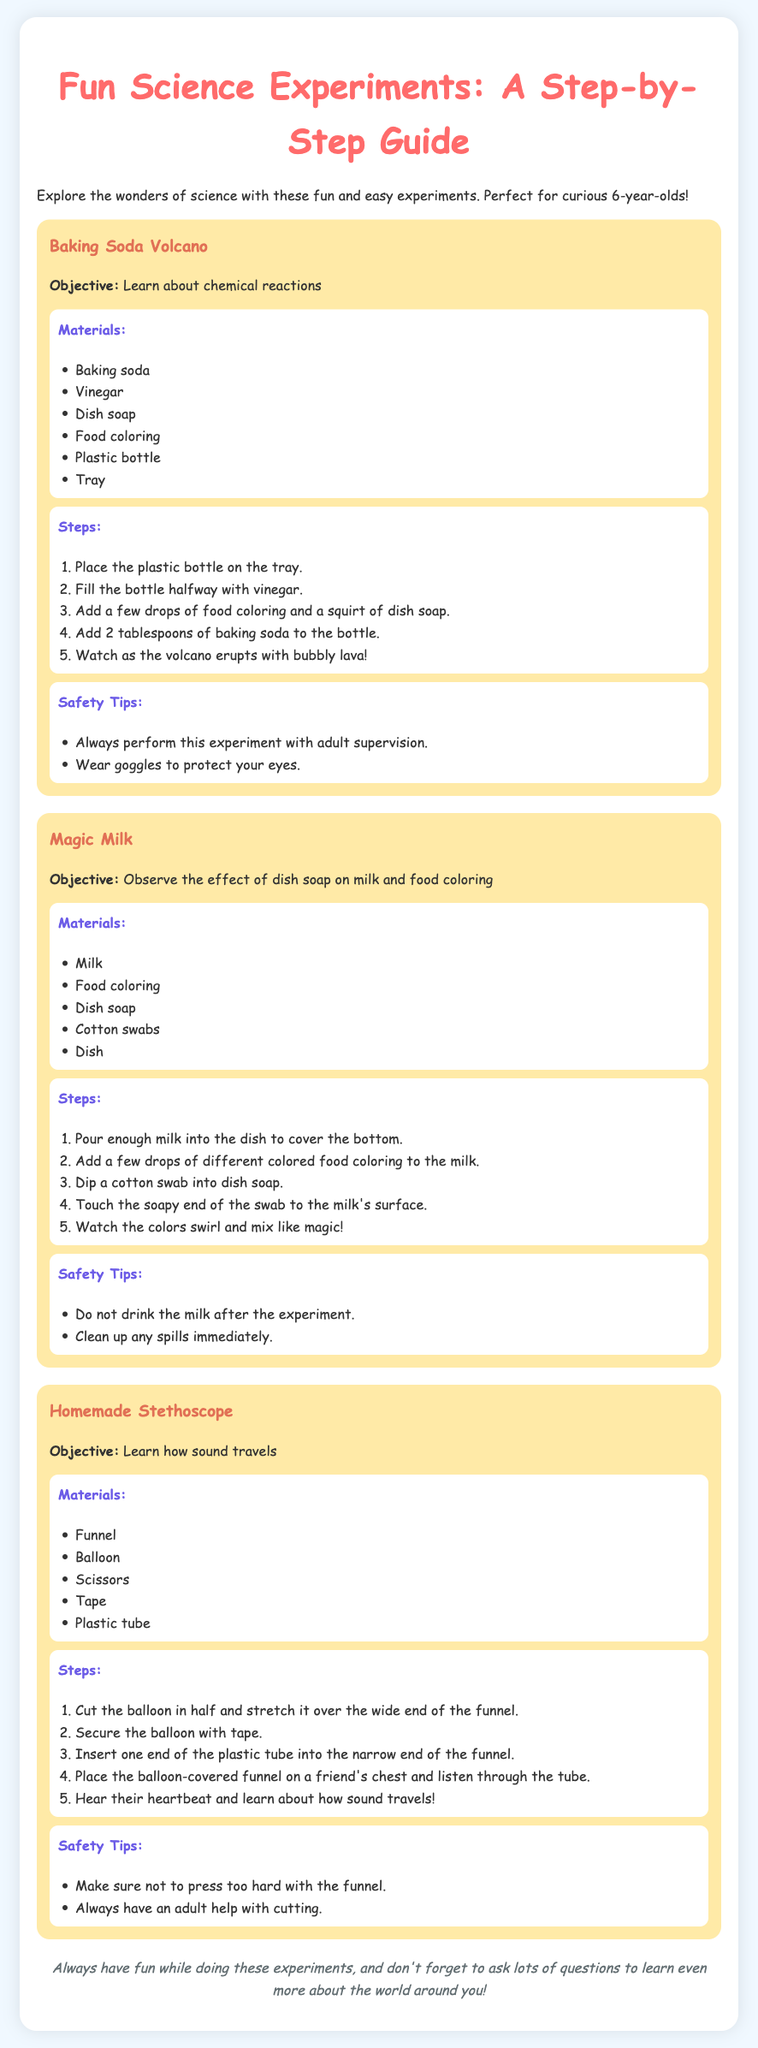What is the first experiment listed? The first experiment in the document is titled "Baking Soda Volcano."
Answer: Baking Soda Volcano How many materials are needed for the Magic Milk experiment? The Magic Milk experiment requires a total of five materials as listed.
Answer: Five What color is the background of the document? The document features a background color that is light blue, often described as #f0f8ff.
Answer: Light blue What is the objective of the Homemade Stethoscope experiment? The goal of the Homemade Stethoscope experiment is to learn about how sound travels.
Answer: Learn how sound travels What should you wear for safety when doing the Baking Soda Volcano? The document advises wearing goggles to protect the eyes during the Baking Soda Volcano experiment.
Answer: Goggles How should the funnel be prepared for the Homemade Stethoscope? The funnel needs to have a balloon stretched over its wide end, which is secured with tape as part of its preparation.
Answer: Balloon stretched over wide end What happens when dish soap is added to the Magic Milk experiment? Adding dish soap to the milk's surface causes the colors to swirl and mix, creating a magical effect.
Answer: Colors swirl and mix How should spills be handled during the Magic Milk experiment? It is advised to clean up any spills immediately as part of following safety tips during the experiment.
Answer: Clean up spills immediately 